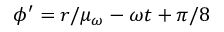Convert formula to latex. <formula><loc_0><loc_0><loc_500><loc_500>\phi ^ { \prime } = r / \mu _ { \omega } - \omega t + \pi / 8</formula> 